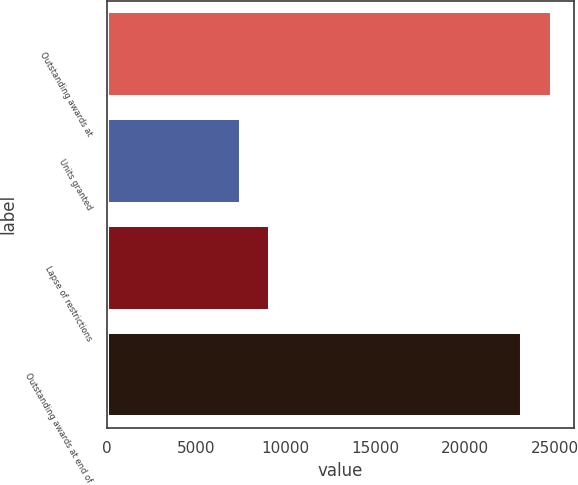Convert chart to OTSL. <chart><loc_0><loc_0><loc_500><loc_500><bar_chart><fcel>Outstanding awards at<fcel>Units granted<fcel>Lapse of restrictions<fcel>Outstanding awards at end of<nl><fcel>24829.3<fcel>7492<fcel>9129.3<fcel>23192<nl></chart> 